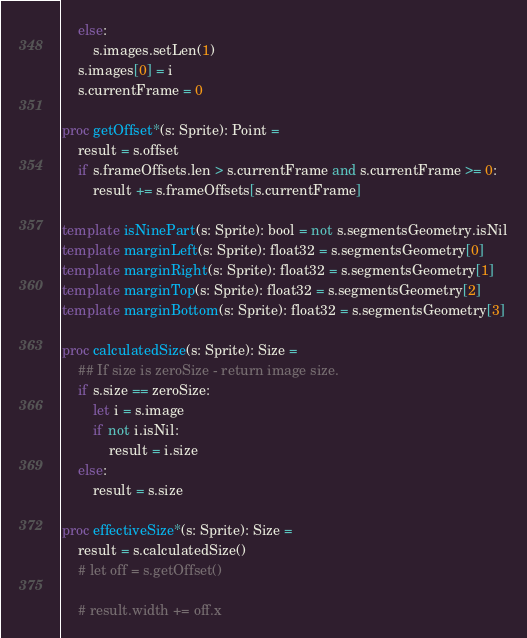Convert code to text. <code><loc_0><loc_0><loc_500><loc_500><_Nim_>    else:
        s.images.setLen(1)
    s.images[0] = i
    s.currentFrame = 0

proc getOffset*(s: Sprite): Point =
    result = s.offset
    if s.frameOffsets.len > s.currentFrame and s.currentFrame >= 0:
        result += s.frameOffsets[s.currentFrame]

template isNinePart(s: Sprite): bool = not s.segmentsGeometry.isNil
template marginLeft(s: Sprite): float32 = s.segmentsGeometry[0]
template marginRight(s: Sprite): float32 = s.segmentsGeometry[1]
template marginTop(s: Sprite): float32 = s.segmentsGeometry[2]
template marginBottom(s: Sprite): float32 = s.segmentsGeometry[3]

proc calculatedSize(s: Sprite): Size =
    ## If size is zeroSize - return image size.
    if s.size == zeroSize:
        let i = s.image
        if not i.isNil:
            result = i.size
    else:
        result = s.size

proc effectiveSize*(s: Sprite): Size =
    result = s.calculatedSize()
    # let off = s.getOffset()

    # result.width += off.x</code> 